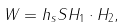<formula> <loc_0><loc_0><loc_500><loc_500>W = h _ { s } S H _ { 1 } \cdot H _ { 2 } ,</formula> 